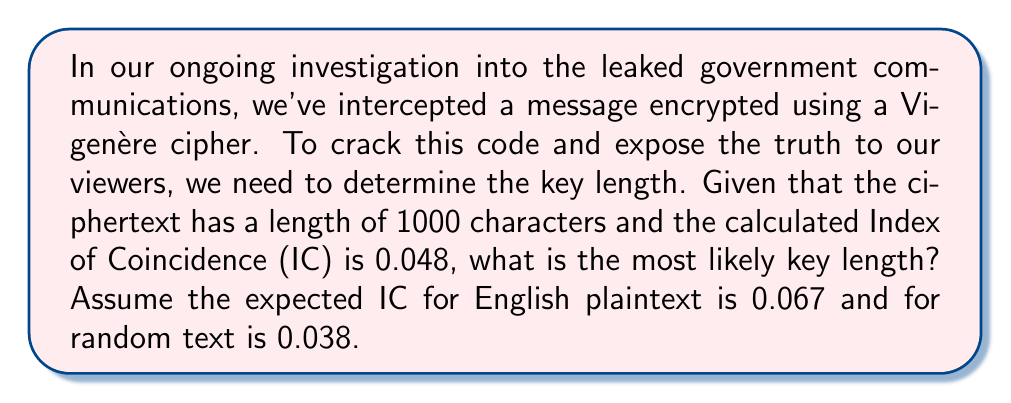What is the answer to this math problem? To determine the key length in a Vigenère cipher using the Index of Coincidence, we'll follow these steps:

1) The formula for the Index of Coincidence in a Vigenère cipher is:

   $$IC = \frac{1}{L} \cdot IC_{plain} + \frac{L-1}{L} \cdot IC_{random}$$

   Where $L$ is the key length, $IC_{plain}$ is the IC for plaintext, and $IC_{random}$ is the IC for random text.

2) We're given:
   $IC = 0.048$
   $IC_{plain} = 0.067$
   $IC_{random} = 0.038$

3) Let's substitute these values into the formula:

   $$0.048 = \frac{1}{L} \cdot 0.067 + \frac{L-1}{L} \cdot 0.038$$

4) Simplify:
   $$0.048 = \frac{0.067}{L} + 0.038 - \frac{0.038}{L}$$

5) Multiply both sides by $L$:
   $$0.048L = 0.067 + 0.038L - 0.038$$

6) Simplify:
   $$0.048L = 0.029 + 0.038L$$

7) Subtract $0.038L$ from both sides:
   $$0.01L = 0.029$$

8) Divide both sides by 0.01:
   $$L = 2.9$$

9) Since the key length must be an integer, we round to the nearest whole number.
Answer: 3 